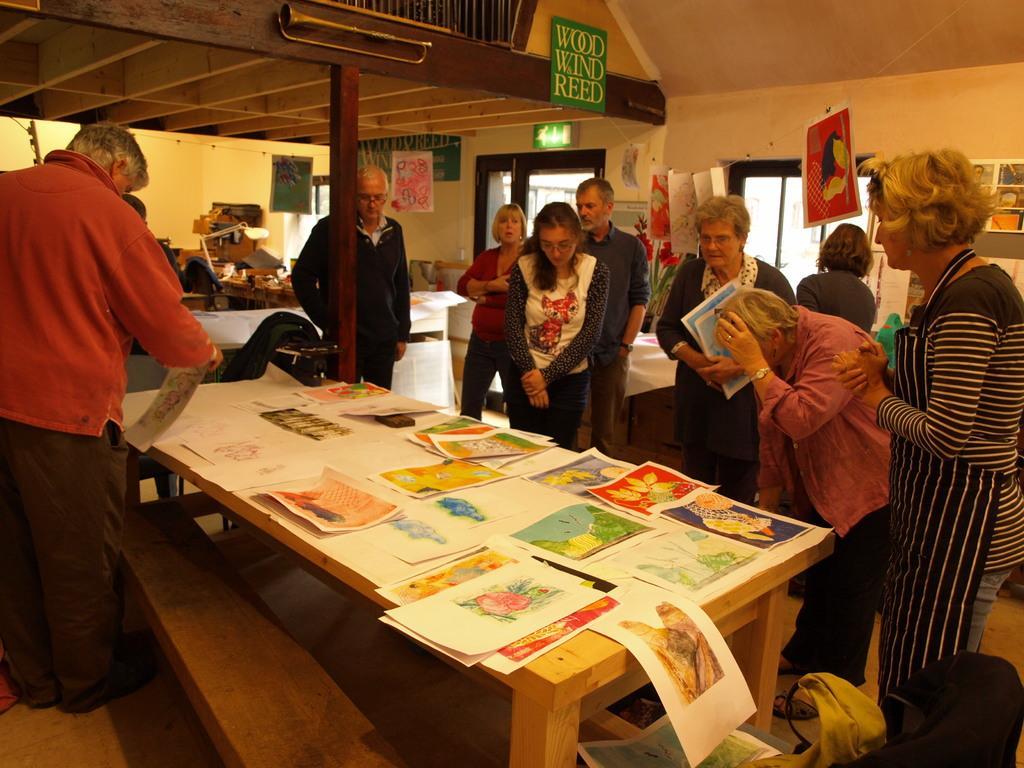Can you describe this image briefly? In this image i can see group of people standing and watching the papers on the table. In the background i can see a table, a light, the roof, musical instruments and few boards. 